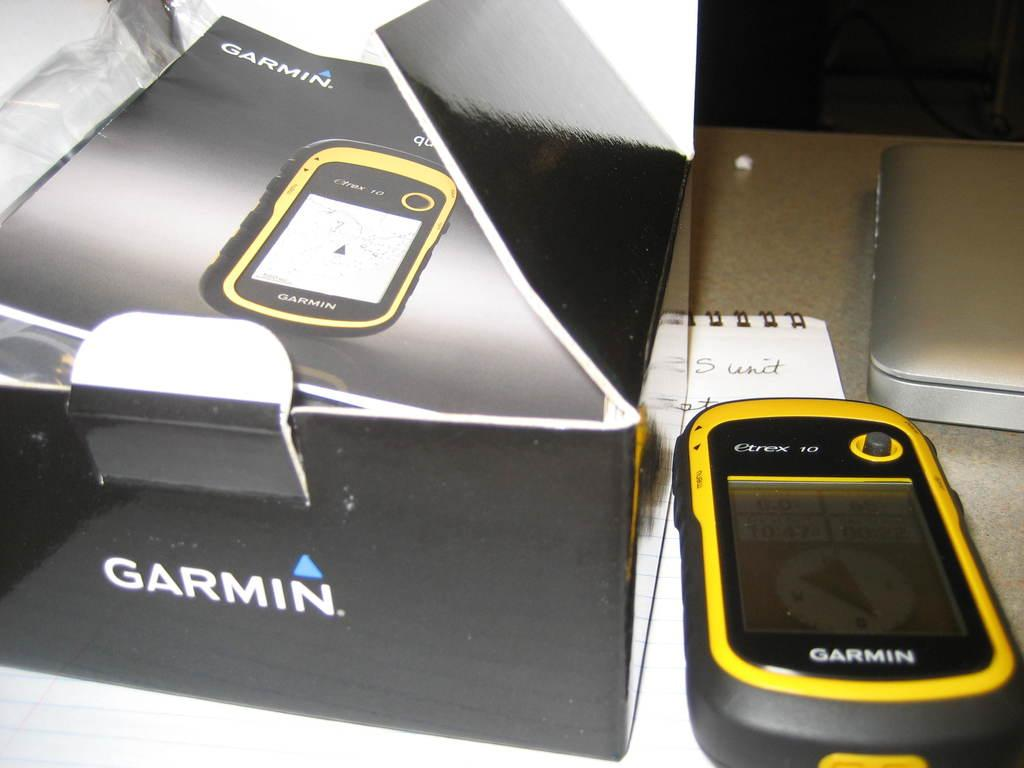<image>
Write a terse but informative summary of the picture. a box that has the word Garmin on it 